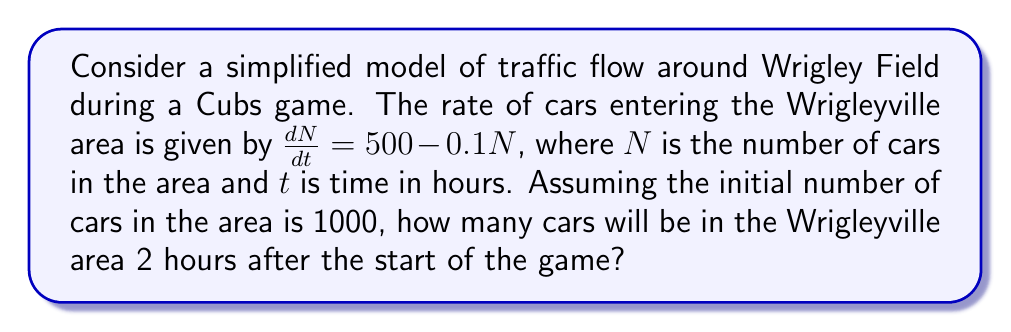Can you solve this math problem? To solve this problem, we need to use the principles of control theory and differential equations. The given equation is a first-order linear differential equation.

1. The general form of the equation is:
   $$\frac{dN}{dt} = 500 - 0.1N$$

2. This can be rewritten as:
   $$\frac{dN}{dt} + 0.1N = 500$$

3. The solution to this type of equation is of the form:
   $$N(t) = N_e + (N_0 - N_e)e^{-kt}$$
   where $N_e$ is the equilibrium point, $N_0$ is the initial value, and $k$ is the rate constant.

4. To find $N_e$, set $\frac{dN}{dt} = 0$:
   $$0 = 500 - 0.1N_e$$
   $$N_e = 5000$$

5. We're given $N_0 = 1000$ and $k = 0.1$

6. Substituting these values into the solution:
   $$N(t) = 5000 + (1000 - 5000)e^{-0.1t}$$
   $$N(t) = 5000 - 4000e^{-0.1t}$$

7. To find the number of cars after 2 hours, substitute $t = 2$:
   $$N(2) = 5000 - 4000e^{-0.1(2)}$$
   $$N(2) = 5000 - 4000e^{-0.2}$$
   $$N(2) = 5000 - 4000(0.8187)$$
   $$N(2) = 5000 - 3274.8$$
   $$N(2) = 1725.2$$

8. Rounding to the nearest whole number (as we can't have a fraction of a car):
   $$N(2) \approx 1725$$
Answer: After 2 hours, there will be approximately 1725 cars in the Wrigleyville area. 